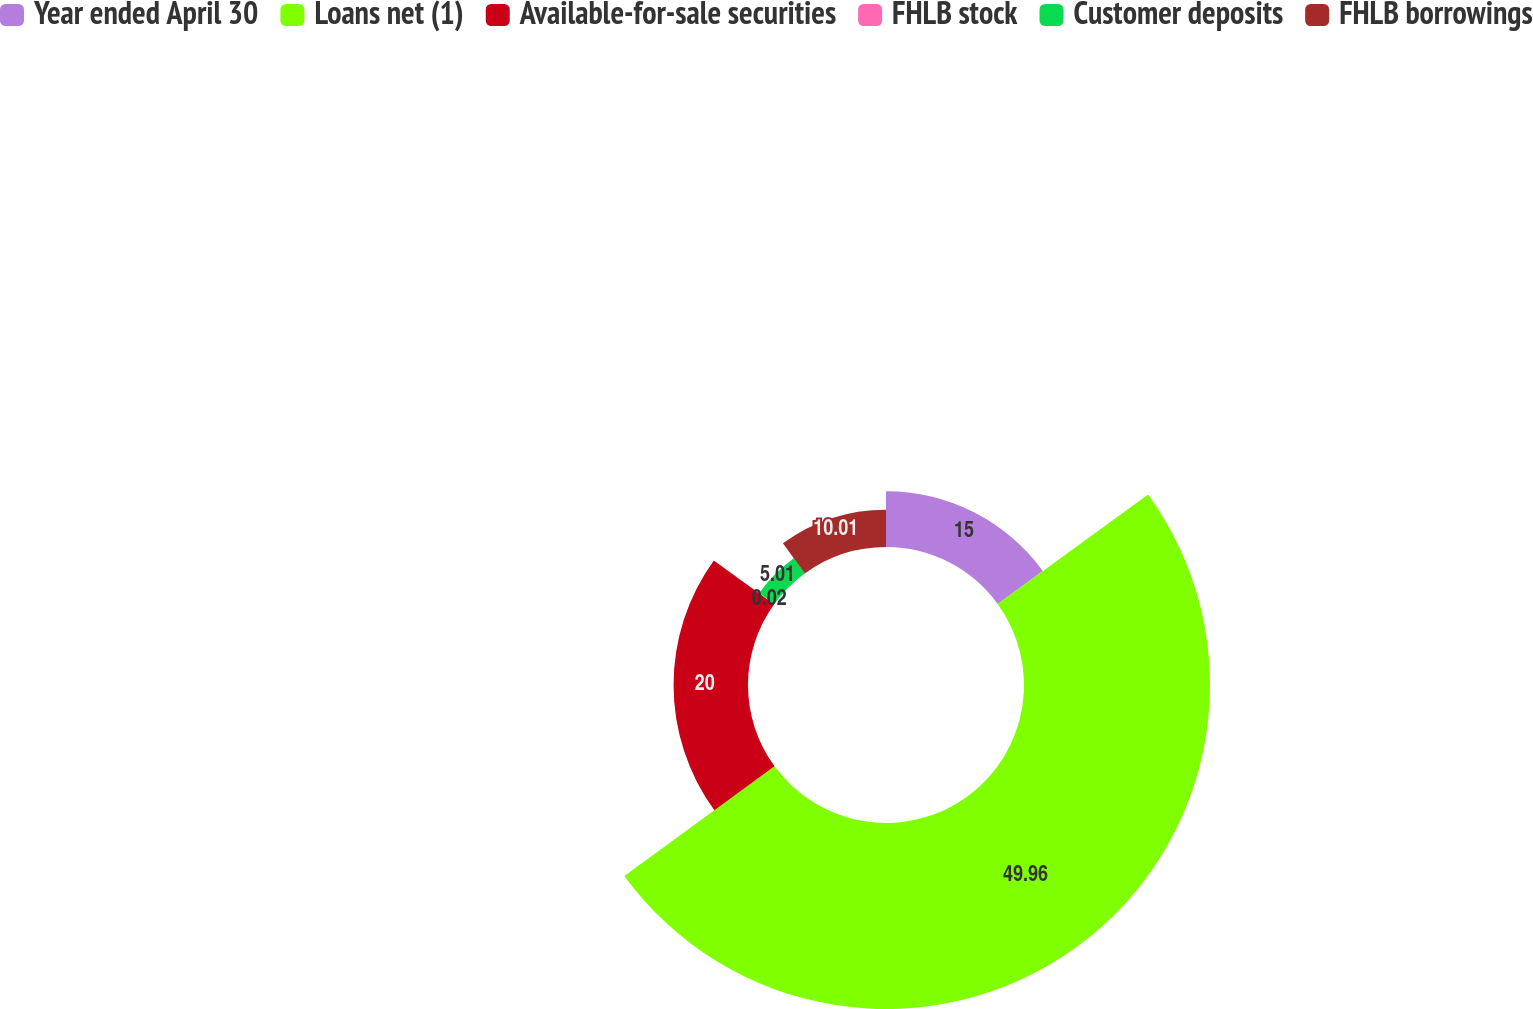Convert chart. <chart><loc_0><loc_0><loc_500><loc_500><pie_chart><fcel>Year ended April 30<fcel>Loans net (1)<fcel>Available-for-sale securities<fcel>FHLB stock<fcel>Customer deposits<fcel>FHLB borrowings<nl><fcel>15.0%<fcel>49.97%<fcel>20.0%<fcel>0.02%<fcel>5.01%<fcel>10.01%<nl></chart> 